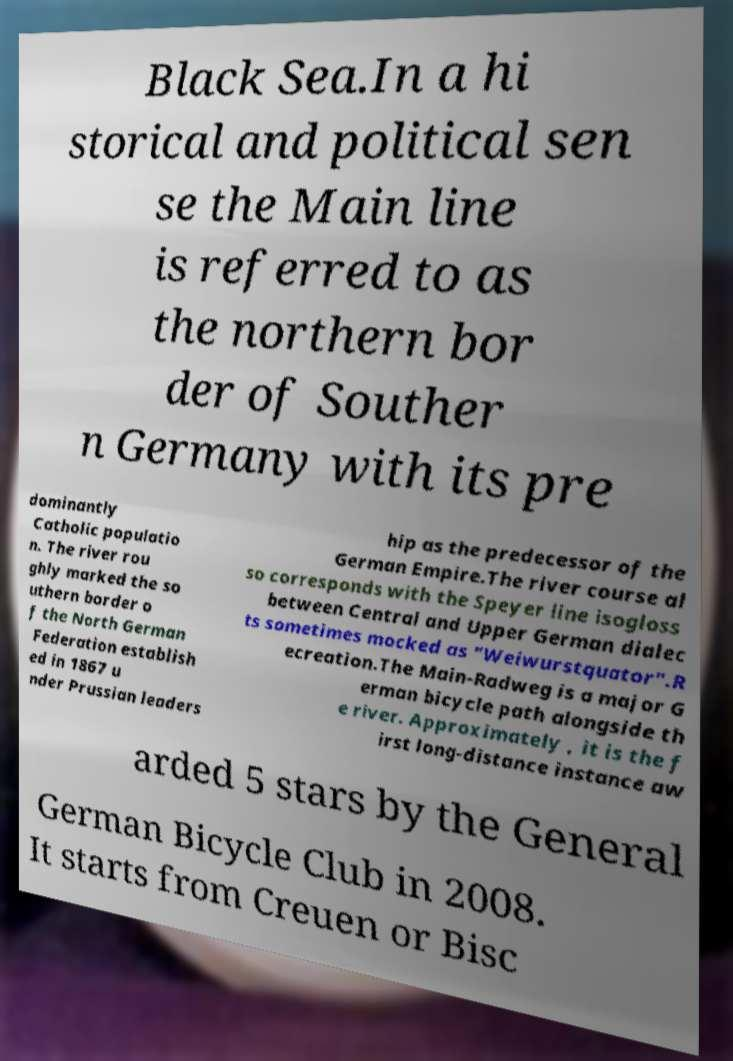Could you assist in decoding the text presented in this image and type it out clearly? Black Sea.In a hi storical and political sen se the Main line is referred to as the northern bor der of Souther n Germany with its pre dominantly Catholic populatio n. The river rou ghly marked the so uthern border o f the North German Federation establish ed in 1867 u nder Prussian leaders hip as the predecessor of the German Empire.The river course al so corresponds with the Speyer line isogloss between Central and Upper German dialec ts sometimes mocked as "Weiwurstquator".R ecreation.The Main-Radweg is a major G erman bicycle path alongside th e river. Approximately , it is the f irst long-distance instance aw arded 5 stars by the General German Bicycle Club in 2008. It starts from Creuen or Bisc 